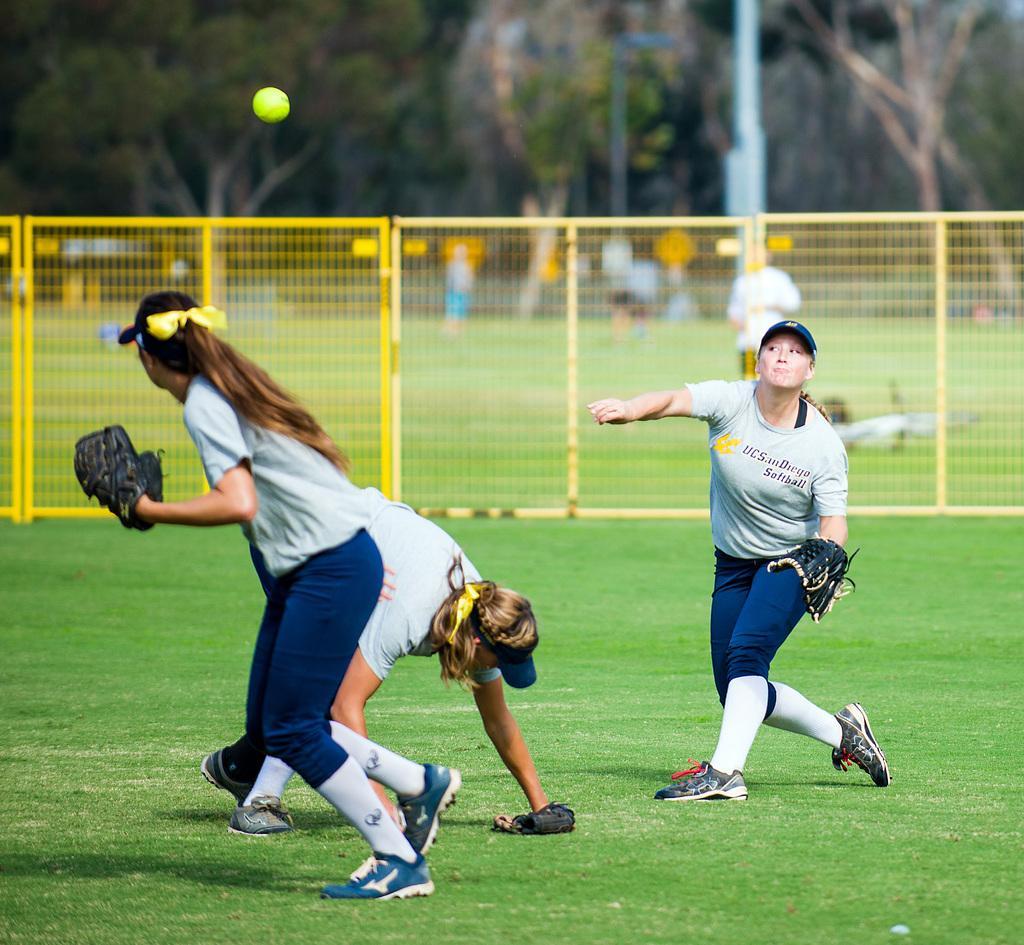Could you give a brief overview of what you see in this image? In this image there are a few people playing on the ground with a ball which is in the air, behind them there is a net fence, behind that there are a few people standing. In the background there are trees and a pole. 